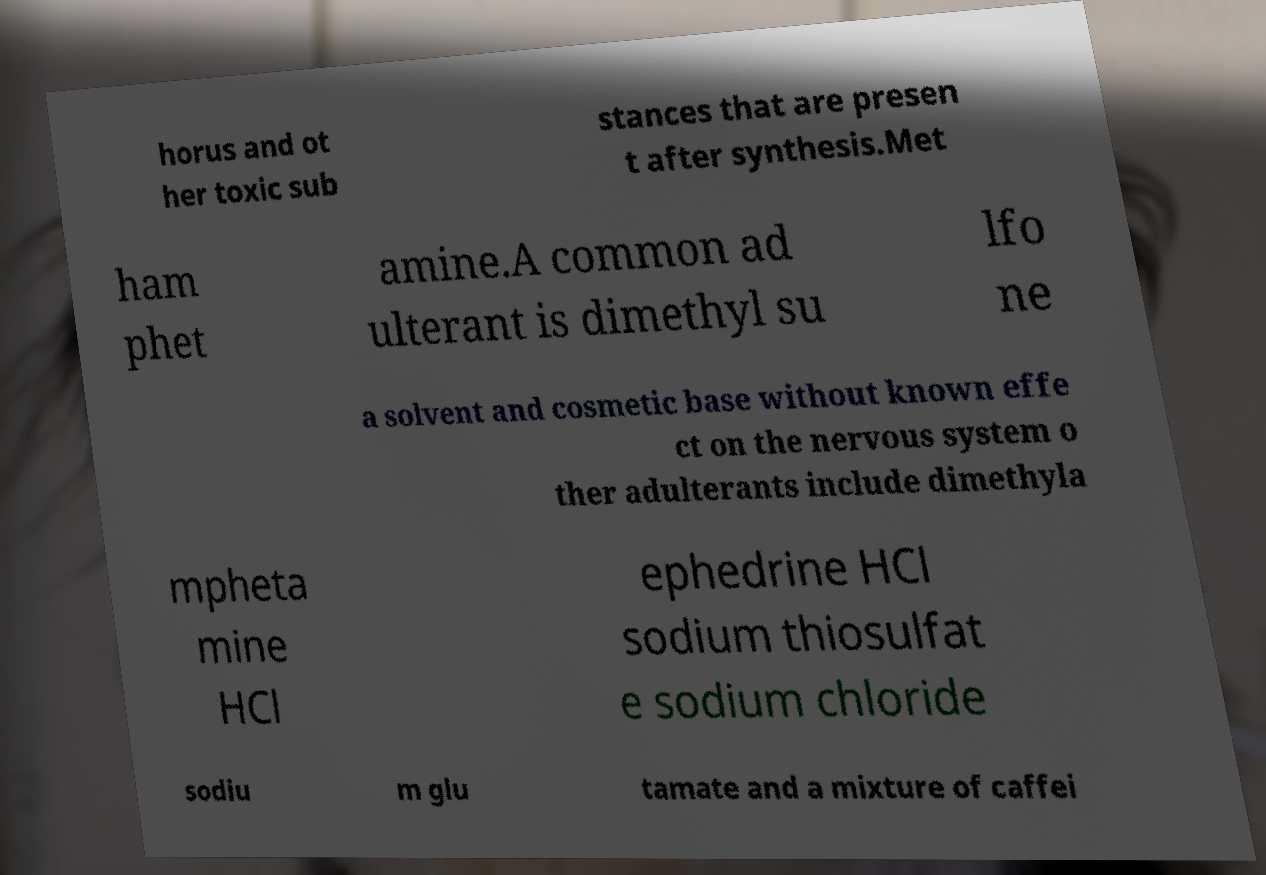Can you read and provide the text displayed in the image?This photo seems to have some interesting text. Can you extract and type it out for me? horus and ot her toxic sub stances that are presen t after synthesis.Met ham phet amine.A common ad ulterant is dimethyl su lfo ne a solvent and cosmetic base without known effe ct on the nervous system o ther adulterants include dimethyla mpheta mine HCl ephedrine HCl sodium thiosulfat e sodium chloride sodiu m glu tamate and a mixture of caffei 